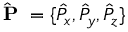<formula> <loc_0><loc_0><loc_500><loc_500>\hat { P } = \{ \hat { P } _ { x } , \hat { P } _ { y } , \hat { P } _ { z } \}</formula> 